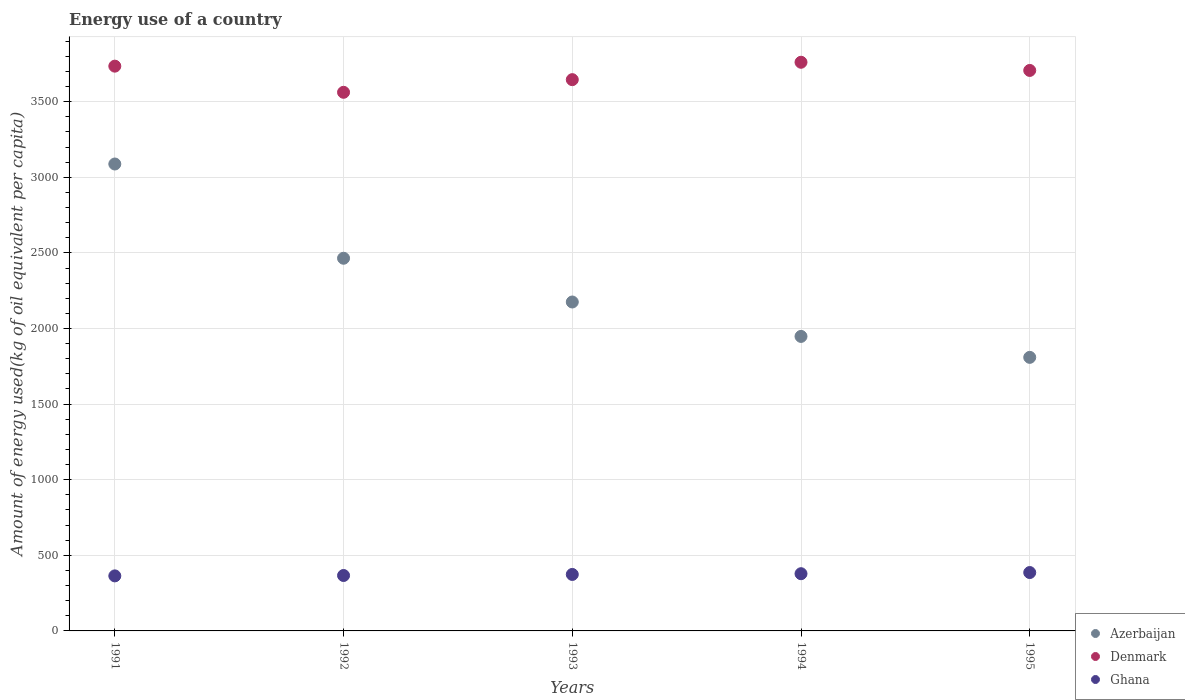Is the number of dotlines equal to the number of legend labels?
Offer a terse response. Yes. What is the amount of energy used in in Azerbaijan in 1991?
Give a very brief answer. 3087.87. Across all years, what is the maximum amount of energy used in in Ghana?
Your answer should be very brief. 386.09. Across all years, what is the minimum amount of energy used in in Ghana?
Your answer should be very brief. 363.97. What is the total amount of energy used in in Ghana in the graph?
Your response must be concise. 1868.5. What is the difference between the amount of energy used in in Denmark in 1993 and that in 1995?
Offer a very short reply. -60.93. What is the difference between the amount of energy used in in Azerbaijan in 1994 and the amount of energy used in in Denmark in 1995?
Provide a short and direct response. -1758.96. What is the average amount of energy used in in Azerbaijan per year?
Provide a short and direct response. 2296.92. In the year 1991, what is the difference between the amount of energy used in in Ghana and amount of energy used in in Denmark?
Ensure brevity in your answer.  -3371.06. In how many years, is the amount of energy used in in Azerbaijan greater than 2000 kg?
Make the answer very short. 3. What is the ratio of the amount of energy used in in Ghana in 1991 to that in 1993?
Your answer should be very brief. 0.97. Is the difference between the amount of energy used in in Ghana in 1994 and 1995 greater than the difference between the amount of energy used in in Denmark in 1994 and 1995?
Give a very brief answer. No. What is the difference between the highest and the second highest amount of energy used in in Ghana?
Keep it short and to the point. 7.7. What is the difference between the highest and the lowest amount of energy used in in Denmark?
Make the answer very short. 198.68. In how many years, is the amount of energy used in in Denmark greater than the average amount of energy used in in Denmark taken over all years?
Your answer should be very brief. 3. Is it the case that in every year, the sum of the amount of energy used in in Denmark and amount of energy used in in Azerbaijan  is greater than the amount of energy used in in Ghana?
Your answer should be compact. Yes. Does the amount of energy used in in Denmark monotonically increase over the years?
Your answer should be compact. No. Is the amount of energy used in in Denmark strictly greater than the amount of energy used in in Azerbaijan over the years?
Provide a short and direct response. Yes. How many years are there in the graph?
Keep it short and to the point. 5. Are the values on the major ticks of Y-axis written in scientific E-notation?
Your answer should be very brief. No. Where does the legend appear in the graph?
Your answer should be compact. Bottom right. How many legend labels are there?
Make the answer very short. 3. What is the title of the graph?
Your response must be concise. Energy use of a country. What is the label or title of the X-axis?
Offer a very short reply. Years. What is the label or title of the Y-axis?
Make the answer very short. Amount of energy used(kg of oil equivalent per capita). What is the Amount of energy used(kg of oil equivalent per capita) of Azerbaijan in 1991?
Your answer should be very brief. 3087.87. What is the Amount of energy used(kg of oil equivalent per capita) of Denmark in 1991?
Your answer should be compact. 3735.03. What is the Amount of energy used(kg of oil equivalent per capita) of Ghana in 1991?
Give a very brief answer. 363.97. What is the Amount of energy used(kg of oil equivalent per capita) in Azerbaijan in 1992?
Your answer should be compact. 2464.6. What is the Amount of energy used(kg of oil equivalent per capita) in Denmark in 1992?
Provide a short and direct response. 3562.1. What is the Amount of energy used(kg of oil equivalent per capita) of Ghana in 1992?
Your answer should be compact. 366.52. What is the Amount of energy used(kg of oil equivalent per capita) in Azerbaijan in 1993?
Provide a short and direct response. 2175.28. What is the Amount of energy used(kg of oil equivalent per capita) of Denmark in 1993?
Your answer should be very brief. 3645.72. What is the Amount of energy used(kg of oil equivalent per capita) of Ghana in 1993?
Make the answer very short. 373.52. What is the Amount of energy used(kg of oil equivalent per capita) in Azerbaijan in 1994?
Provide a succinct answer. 1947.69. What is the Amount of energy used(kg of oil equivalent per capita) of Denmark in 1994?
Provide a succinct answer. 3760.77. What is the Amount of energy used(kg of oil equivalent per capita) in Ghana in 1994?
Provide a succinct answer. 378.39. What is the Amount of energy used(kg of oil equivalent per capita) of Azerbaijan in 1995?
Provide a succinct answer. 1809.15. What is the Amount of energy used(kg of oil equivalent per capita) in Denmark in 1995?
Your answer should be very brief. 3706.65. What is the Amount of energy used(kg of oil equivalent per capita) in Ghana in 1995?
Offer a very short reply. 386.09. Across all years, what is the maximum Amount of energy used(kg of oil equivalent per capita) of Azerbaijan?
Provide a short and direct response. 3087.87. Across all years, what is the maximum Amount of energy used(kg of oil equivalent per capita) of Denmark?
Provide a short and direct response. 3760.77. Across all years, what is the maximum Amount of energy used(kg of oil equivalent per capita) in Ghana?
Provide a short and direct response. 386.09. Across all years, what is the minimum Amount of energy used(kg of oil equivalent per capita) in Azerbaijan?
Provide a succinct answer. 1809.15. Across all years, what is the minimum Amount of energy used(kg of oil equivalent per capita) of Denmark?
Offer a very short reply. 3562.1. Across all years, what is the minimum Amount of energy used(kg of oil equivalent per capita) in Ghana?
Provide a succinct answer. 363.97. What is the total Amount of energy used(kg of oil equivalent per capita) in Azerbaijan in the graph?
Make the answer very short. 1.15e+04. What is the total Amount of energy used(kg of oil equivalent per capita) of Denmark in the graph?
Provide a succinct answer. 1.84e+04. What is the total Amount of energy used(kg of oil equivalent per capita) in Ghana in the graph?
Keep it short and to the point. 1868.5. What is the difference between the Amount of energy used(kg of oil equivalent per capita) in Azerbaijan in 1991 and that in 1992?
Make the answer very short. 623.28. What is the difference between the Amount of energy used(kg of oil equivalent per capita) of Denmark in 1991 and that in 1992?
Offer a very short reply. 172.93. What is the difference between the Amount of energy used(kg of oil equivalent per capita) in Ghana in 1991 and that in 1992?
Give a very brief answer. -2.55. What is the difference between the Amount of energy used(kg of oil equivalent per capita) of Azerbaijan in 1991 and that in 1993?
Your answer should be compact. 912.59. What is the difference between the Amount of energy used(kg of oil equivalent per capita) in Denmark in 1991 and that in 1993?
Provide a short and direct response. 89.3. What is the difference between the Amount of energy used(kg of oil equivalent per capita) in Ghana in 1991 and that in 1993?
Ensure brevity in your answer.  -9.56. What is the difference between the Amount of energy used(kg of oil equivalent per capita) of Azerbaijan in 1991 and that in 1994?
Give a very brief answer. 1140.18. What is the difference between the Amount of energy used(kg of oil equivalent per capita) in Denmark in 1991 and that in 1994?
Offer a very short reply. -25.75. What is the difference between the Amount of energy used(kg of oil equivalent per capita) in Ghana in 1991 and that in 1994?
Offer a terse response. -14.42. What is the difference between the Amount of energy used(kg of oil equivalent per capita) of Azerbaijan in 1991 and that in 1995?
Offer a very short reply. 1278.72. What is the difference between the Amount of energy used(kg of oil equivalent per capita) of Denmark in 1991 and that in 1995?
Your answer should be compact. 28.37. What is the difference between the Amount of energy used(kg of oil equivalent per capita) in Ghana in 1991 and that in 1995?
Give a very brief answer. -22.12. What is the difference between the Amount of energy used(kg of oil equivalent per capita) of Azerbaijan in 1992 and that in 1993?
Provide a short and direct response. 289.31. What is the difference between the Amount of energy used(kg of oil equivalent per capita) of Denmark in 1992 and that in 1993?
Ensure brevity in your answer.  -83.62. What is the difference between the Amount of energy used(kg of oil equivalent per capita) of Ghana in 1992 and that in 1993?
Provide a short and direct response. -7. What is the difference between the Amount of energy used(kg of oil equivalent per capita) in Azerbaijan in 1992 and that in 1994?
Your answer should be very brief. 516.91. What is the difference between the Amount of energy used(kg of oil equivalent per capita) of Denmark in 1992 and that in 1994?
Your answer should be compact. -198.68. What is the difference between the Amount of energy used(kg of oil equivalent per capita) of Ghana in 1992 and that in 1994?
Your answer should be very brief. -11.87. What is the difference between the Amount of energy used(kg of oil equivalent per capita) of Azerbaijan in 1992 and that in 1995?
Provide a short and direct response. 655.44. What is the difference between the Amount of energy used(kg of oil equivalent per capita) of Denmark in 1992 and that in 1995?
Provide a succinct answer. -144.56. What is the difference between the Amount of energy used(kg of oil equivalent per capita) in Ghana in 1992 and that in 1995?
Your answer should be very brief. -19.57. What is the difference between the Amount of energy used(kg of oil equivalent per capita) in Azerbaijan in 1993 and that in 1994?
Ensure brevity in your answer.  227.59. What is the difference between the Amount of energy used(kg of oil equivalent per capita) in Denmark in 1993 and that in 1994?
Keep it short and to the point. -115.05. What is the difference between the Amount of energy used(kg of oil equivalent per capita) of Ghana in 1993 and that in 1994?
Make the answer very short. -4.87. What is the difference between the Amount of energy used(kg of oil equivalent per capita) of Azerbaijan in 1993 and that in 1995?
Your answer should be very brief. 366.13. What is the difference between the Amount of energy used(kg of oil equivalent per capita) in Denmark in 1993 and that in 1995?
Your answer should be compact. -60.93. What is the difference between the Amount of energy used(kg of oil equivalent per capita) in Ghana in 1993 and that in 1995?
Your response must be concise. -12.57. What is the difference between the Amount of energy used(kg of oil equivalent per capita) in Azerbaijan in 1994 and that in 1995?
Offer a terse response. 138.54. What is the difference between the Amount of energy used(kg of oil equivalent per capita) in Denmark in 1994 and that in 1995?
Provide a succinct answer. 54.12. What is the difference between the Amount of energy used(kg of oil equivalent per capita) in Ghana in 1994 and that in 1995?
Offer a very short reply. -7.7. What is the difference between the Amount of energy used(kg of oil equivalent per capita) of Azerbaijan in 1991 and the Amount of energy used(kg of oil equivalent per capita) of Denmark in 1992?
Provide a succinct answer. -474.22. What is the difference between the Amount of energy used(kg of oil equivalent per capita) of Azerbaijan in 1991 and the Amount of energy used(kg of oil equivalent per capita) of Ghana in 1992?
Provide a succinct answer. 2721.35. What is the difference between the Amount of energy used(kg of oil equivalent per capita) of Denmark in 1991 and the Amount of energy used(kg of oil equivalent per capita) of Ghana in 1992?
Your answer should be compact. 3368.5. What is the difference between the Amount of energy used(kg of oil equivalent per capita) in Azerbaijan in 1991 and the Amount of energy used(kg of oil equivalent per capita) in Denmark in 1993?
Your response must be concise. -557.85. What is the difference between the Amount of energy used(kg of oil equivalent per capita) of Azerbaijan in 1991 and the Amount of energy used(kg of oil equivalent per capita) of Ghana in 1993?
Keep it short and to the point. 2714.35. What is the difference between the Amount of energy used(kg of oil equivalent per capita) of Denmark in 1991 and the Amount of energy used(kg of oil equivalent per capita) of Ghana in 1993?
Keep it short and to the point. 3361.5. What is the difference between the Amount of energy used(kg of oil equivalent per capita) of Azerbaijan in 1991 and the Amount of energy used(kg of oil equivalent per capita) of Denmark in 1994?
Your response must be concise. -672.9. What is the difference between the Amount of energy used(kg of oil equivalent per capita) of Azerbaijan in 1991 and the Amount of energy used(kg of oil equivalent per capita) of Ghana in 1994?
Make the answer very short. 2709.48. What is the difference between the Amount of energy used(kg of oil equivalent per capita) in Denmark in 1991 and the Amount of energy used(kg of oil equivalent per capita) in Ghana in 1994?
Your answer should be very brief. 3356.64. What is the difference between the Amount of energy used(kg of oil equivalent per capita) of Azerbaijan in 1991 and the Amount of energy used(kg of oil equivalent per capita) of Denmark in 1995?
Offer a terse response. -618.78. What is the difference between the Amount of energy used(kg of oil equivalent per capita) of Azerbaijan in 1991 and the Amount of energy used(kg of oil equivalent per capita) of Ghana in 1995?
Offer a very short reply. 2701.78. What is the difference between the Amount of energy used(kg of oil equivalent per capita) of Denmark in 1991 and the Amount of energy used(kg of oil equivalent per capita) of Ghana in 1995?
Offer a very short reply. 3348.93. What is the difference between the Amount of energy used(kg of oil equivalent per capita) in Azerbaijan in 1992 and the Amount of energy used(kg of oil equivalent per capita) in Denmark in 1993?
Your response must be concise. -1181.12. What is the difference between the Amount of energy used(kg of oil equivalent per capita) of Azerbaijan in 1992 and the Amount of energy used(kg of oil equivalent per capita) of Ghana in 1993?
Your answer should be very brief. 2091.07. What is the difference between the Amount of energy used(kg of oil equivalent per capita) in Denmark in 1992 and the Amount of energy used(kg of oil equivalent per capita) in Ghana in 1993?
Keep it short and to the point. 3188.57. What is the difference between the Amount of energy used(kg of oil equivalent per capita) in Azerbaijan in 1992 and the Amount of energy used(kg of oil equivalent per capita) in Denmark in 1994?
Provide a succinct answer. -1296.18. What is the difference between the Amount of energy used(kg of oil equivalent per capita) of Azerbaijan in 1992 and the Amount of energy used(kg of oil equivalent per capita) of Ghana in 1994?
Offer a terse response. 2086.21. What is the difference between the Amount of energy used(kg of oil equivalent per capita) in Denmark in 1992 and the Amount of energy used(kg of oil equivalent per capita) in Ghana in 1994?
Keep it short and to the point. 3183.71. What is the difference between the Amount of energy used(kg of oil equivalent per capita) in Azerbaijan in 1992 and the Amount of energy used(kg of oil equivalent per capita) in Denmark in 1995?
Ensure brevity in your answer.  -1242.06. What is the difference between the Amount of energy used(kg of oil equivalent per capita) in Azerbaijan in 1992 and the Amount of energy used(kg of oil equivalent per capita) in Ghana in 1995?
Your answer should be very brief. 2078.51. What is the difference between the Amount of energy used(kg of oil equivalent per capita) of Denmark in 1992 and the Amount of energy used(kg of oil equivalent per capita) of Ghana in 1995?
Provide a short and direct response. 3176.01. What is the difference between the Amount of energy used(kg of oil equivalent per capita) of Azerbaijan in 1993 and the Amount of energy used(kg of oil equivalent per capita) of Denmark in 1994?
Your answer should be compact. -1585.49. What is the difference between the Amount of energy used(kg of oil equivalent per capita) in Azerbaijan in 1993 and the Amount of energy used(kg of oil equivalent per capita) in Ghana in 1994?
Your answer should be very brief. 1796.89. What is the difference between the Amount of energy used(kg of oil equivalent per capita) of Denmark in 1993 and the Amount of energy used(kg of oil equivalent per capita) of Ghana in 1994?
Keep it short and to the point. 3267.33. What is the difference between the Amount of energy used(kg of oil equivalent per capita) in Azerbaijan in 1993 and the Amount of energy used(kg of oil equivalent per capita) in Denmark in 1995?
Make the answer very short. -1531.37. What is the difference between the Amount of energy used(kg of oil equivalent per capita) in Azerbaijan in 1993 and the Amount of energy used(kg of oil equivalent per capita) in Ghana in 1995?
Provide a short and direct response. 1789.19. What is the difference between the Amount of energy used(kg of oil equivalent per capita) in Denmark in 1993 and the Amount of energy used(kg of oil equivalent per capita) in Ghana in 1995?
Your answer should be very brief. 3259.63. What is the difference between the Amount of energy used(kg of oil equivalent per capita) of Azerbaijan in 1994 and the Amount of energy used(kg of oil equivalent per capita) of Denmark in 1995?
Your answer should be compact. -1758.96. What is the difference between the Amount of energy used(kg of oil equivalent per capita) of Azerbaijan in 1994 and the Amount of energy used(kg of oil equivalent per capita) of Ghana in 1995?
Your answer should be compact. 1561.6. What is the difference between the Amount of energy used(kg of oil equivalent per capita) in Denmark in 1994 and the Amount of energy used(kg of oil equivalent per capita) in Ghana in 1995?
Make the answer very short. 3374.68. What is the average Amount of energy used(kg of oil equivalent per capita) of Azerbaijan per year?
Give a very brief answer. 2296.92. What is the average Amount of energy used(kg of oil equivalent per capita) in Denmark per year?
Give a very brief answer. 3682.06. What is the average Amount of energy used(kg of oil equivalent per capita) of Ghana per year?
Give a very brief answer. 373.7. In the year 1991, what is the difference between the Amount of energy used(kg of oil equivalent per capita) in Azerbaijan and Amount of energy used(kg of oil equivalent per capita) in Denmark?
Offer a terse response. -647.15. In the year 1991, what is the difference between the Amount of energy used(kg of oil equivalent per capita) in Azerbaijan and Amount of energy used(kg of oil equivalent per capita) in Ghana?
Ensure brevity in your answer.  2723.91. In the year 1991, what is the difference between the Amount of energy used(kg of oil equivalent per capita) in Denmark and Amount of energy used(kg of oil equivalent per capita) in Ghana?
Your answer should be compact. 3371.06. In the year 1992, what is the difference between the Amount of energy used(kg of oil equivalent per capita) of Azerbaijan and Amount of energy used(kg of oil equivalent per capita) of Denmark?
Make the answer very short. -1097.5. In the year 1992, what is the difference between the Amount of energy used(kg of oil equivalent per capita) in Azerbaijan and Amount of energy used(kg of oil equivalent per capita) in Ghana?
Provide a succinct answer. 2098.07. In the year 1992, what is the difference between the Amount of energy used(kg of oil equivalent per capita) of Denmark and Amount of energy used(kg of oil equivalent per capita) of Ghana?
Give a very brief answer. 3195.58. In the year 1993, what is the difference between the Amount of energy used(kg of oil equivalent per capita) of Azerbaijan and Amount of energy used(kg of oil equivalent per capita) of Denmark?
Provide a succinct answer. -1470.44. In the year 1993, what is the difference between the Amount of energy used(kg of oil equivalent per capita) of Azerbaijan and Amount of energy used(kg of oil equivalent per capita) of Ghana?
Your response must be concise. 1801.76. In the year 1993, what is the difference between the Amount of energy used(kg of oil equivalent per capita) of Denmark and Amount of energy used(kg of oil equivalent per capita) of Ghana?
Give a very brief answer. 3272.2. In the year 1994, what is the difference between the Amount of energy used(kg of oil equivalent per capita) of Azerbaijan and Amount of energy used(kg of oil equivalent per capita) of Denmark?
Keep it short and to the point. -1813.08. In the year 1994, what is the difference between the Amount of energy used(kg of oil equivalent per capita) of Azerbaijan and Amount of energy used(kg of oil equivalent per capita) of Ghana?
Offer a terse response. 1569.3. In the year 1994, what is the difference between the Amount of energy used(kg of oil equivalent per capita) in Denmark and Amount of energy used(kg of oil equivalent per capita) in Ghana?
Ensure brevity in your answer.  3382.38. In the year 1995, what is the difference between the Amount of energy used(kg of oil equivalent per capita) in Azerbaijan and Amount of energy used(kg of oil equivalent per capita) in Denmark?
Give a very brief answer. -1897.5. In the year 1995, what is the difference between the Amount of energy used(kg of oil equivalent per capita) in Azerbaijan and Amount of energy used(kg of oil equivalent per capita) in Ghana?
Your answer should be compact. 1423.06. In the year 1995, what is the difference between the Amount of energy used(kg of oil equivalent per capita) of Denmark and Amount of energy used(kg of oil equivalent per capita) of Ghana?
Give a very brief answer. 3320.56. What is the ratio of the Amount of energy used(kg of oil equivalent per capita) in Azerbaijan in 1991 to that in 1992?
Your answer should be compact. 1.25. What is the ratio of the Amount of energy used(kg of oil equivalent per capita) in Denmark in 1991 to that in 1992?
Offer a terse response. 1.05. What is the ratio of the Amount of energy used(kg of oil equivalent per capita) in Ghana in 1991 to that in 1992?
Your answer should be compact. 0.99. What is the ratio of the Amount of energy used(kg of oil equivalent per capita) of Azerbaijan in 1991 to that in 1993?
Make the answer very short. 1.42. What is the ratio of the Amount of energy used(kg of oil equivalent per capita) of Denmark in 1991 to that in 1993?
Keep it short and to the point. 1.02. What is the ratio of the Amount of energy used(kg of oil equivalent per capita) in Ghana in 1991 to that in 1993?
Offer a terse response. 0.97. What is the ratio of the Amount of energy used(kg of oil equivalent per capita) in Azerbaijan in 1991 to that in 1994?
Ensure brevity in your answer.  1.59. What is the ratio of the Amount of energy used(kg of oil equivalent per capita) in Denmark in 1991 to that in 1994?
Provide a succinct answer. 0.99. What is the ratio of the Amount of energy used(kg of oil equivalent per capita) of Ghana in 1991 to that in 1994?
Give a very brief answer. 0.96. What is the ratio of the Amount of energy used(kg of oil equivalent per capita) in Azerbaijan in 1991 to that in 1995?
Provide a succinct answer. 1.71. What is the ratio of the Amount of energy used(kg of oil equivalent per capita) in Denmark in 1991 to that in 1995?
Provide a succinct answer. 1.01. What is the ratio of the Amount of energy used(kg of oil equivalent per capita) of Ghana in 1991 to that in 1995?
Provide a succinct answer. 0.94. What is the ratio of the Amount of energy used(kg of oil equivalent per capita) in Azerbaijan in 1992 to that in 1993?
Your response must be concise. 1.13. What is the ratio of the Amount of energy used(kg of oil equivalent per capita) in Denmark in 1992 to that in 1993?
Offer a terse response. 0.98. What is the ratio of the Amount of energy used(kg of oil equivalent per capita) in Ghana in 1992 to that in 1993?
Keep it short and to the point. 0.98. What is the ratio of the Amount of energy used(kg of oil equivalent per capita) of Azerbaijan in 1992 to that in 1994?
Provide a short and direct response. 1.27. What is the ratio of the Amount of energy used(kg of oil equivalent per capita) in Denmark in 1992 to that in 1994?
Offer a very short reply. 0.95. What is the ratio of the Amount of energy used(kg of oil equivalent per capita) in Ghana in 1992 to that in 1994?
Offer a very short reply. 0.97. What is the ratio of the Amount of energy used(kg of oil equivalent per capita) of Azerbaijan in 1992 to that in 1995?
Make the answer very short. 1.36. What is the ratio of the Amount of energy used(kg of oil equivalent per capita) of Denmark in 1992 to that in 1995?
Offer a terse response. 0.96. What is the ratio of the Amount of energy used(kg of oil equivalent per capita) in Ghana in 1992 to that in 1995?
Your response must be concise. 0.95. What is the ratio of the Amount of energy used(kg of oil equivalent per capita) of Azerbaijan in 1993 to that in 1994?
Your answer should be very brief. 1.12. What is the ratio of the Amount of energy used(kg of oil equivalent per capita) in Denmark in 1993 to that in 1994?
Your response must be concise. 0.97. What is the ratio of the Amount of energy used(kg of oil equivalent per capita) in Ghana in 1993 to that in 1994?
Offer a terse response. 0.99. What is the ratio of the Amount of energy used(kg of oil equivalent per capita) of Azerbaijan in 1993 to that in 1995?
Give a very brief answer. 1.2. What is the ratio of the Amount of energy used(kg of oil equivalent per capita) of Denmark in 1993 to that in 1995?
Keep it short and to the point. 0.98. What is the ratio of the Amount of energy used(kg of oil equivalent per capita) of Ghana in 1993 to that in 1995?
Provide a short and direct response. 0.97. What is the ratio of the Amount of energy used(kg of oil equivalent per capita) in Azerbaijan in 1994 to that in 1995?
Provide a succinct answer. 1.08. What is the ratio of the Amount of energy used(kg of oil equivalent per capita) of Denmark in 1994 to that in 1995?
Give a very brief answer. 1.01. What is the ratio of the Amount of energy used(kg of oil equivalent per capita) in Ghana in 1994 to that in 1995?
Ensure brevity in your answer.  0.98. What is the difference between the highest and the second highest Amount of energy used(kg of oil equivalent per capita) in Azerbaijan?
Provide a succinct answer. 623.28. What is the difference between the highest and the second highest Amount of energy used(kg of oil equivalent per capita) of Denmark?
Give a very brief answer. 25.75. What is the difference between the highest and the second highest Amount of energy used(kg of oil equivalent per capita) of Ghana?
Provide a succinct answer. 7.7. What is the difference between the highest and the lowest Amount of energy used(kg of oil equivalent per capita) in Azerbaijan?
Your answer should be very brief. 1278.72. What is the difference between the highest and the lowest Amount of energy used(kg of oil equivalent per capita) in Denmark?
Provide a short and direct response. 198.68. What is the difference between the highest and the lowest Amount of energy used(kg of oil equivalent per capita) in Ghana?
Offer a very short reply. 22.12. 